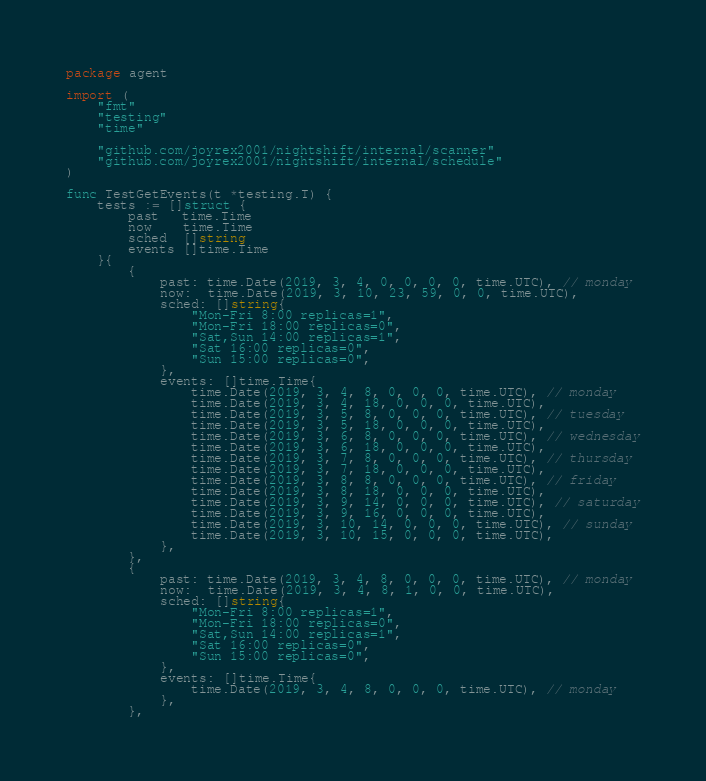<code> <loc_0><loc_0><loc_500><loc_500><_Go_>package agent

import (
	"fmt"
	"testing"
	"time"

	"github.com/joyrex2001/nightshift/internal/scanner"
	"github.com/joyrex2001/nightshift/internal/schedule"
)

func TestGetEvents(t *testing.T) {
	tests := []struct {
		past   time.Time
		now    time.Time
		sched  []string
		events []time.Time
	}{
		{
			past: time.Date(2019, 3, 4, 0, 0, 0, 0, time.UTC), // monday
			now:  time.Date(2019, 3, 10, 23, 59, 0, 0, time.UTC),
			sched: []string{
				"Mon-Fri 8:00 replicas=1",
				"Mon-Fri 18:00 replicas=0",
				"Sat,Sun 14:00 replicas=1",
				"Sat 16:00 replicas=0",
				"Sun 15:00 replicas=0",
			},
			events: []time.Time{
				time.Date(2019, 3, 4, 8, 0, 0, 0, time.UTC), // monday
				time.Date(2019, 3, 4, 18, 0, 0, 0, time.UTC),
				time.Date(2019, 3, 5, 8, 0, 0, 0, time.UTC), // tuesday
				time.Date(2019, 3, 5, 18, 0, 0, 0, time.UTC),
				time.Date(2019, 3, 6, 8, 0, 0, 0, time.UTC), // wednesday
				time.Date(2019, 3, 6, 18, 0, 0, 0, time.UTC),
				time.Date(2019, 3, 7, 8, 0, 0, 0, time.UTC), // thursday
				time.Date(2019, 3, 7, 18, 0, 0, 0, time.UTC),
				time.Date(2019, 3, 8, 8, 0, 0, 0, time.UTC), // friday
				time.Date(2019, 3, 8, 18, 0, 0, 0, time.UTC),
				time.Date(2019, 3, 9, 14, 0, 0, 0, time.UTC), // saturday
				time.Date(2019, 3, 9, 16, 0, 0, 0, time.UTC),
				time.Date(2019, 3, 10, 14, 0, 0, 0, time.UTC), // sunday
				time.Date(2019, 3, 10, 15, 0, 0, 0, time.UTC),
			},
		},
		{
			past: time.Date(2019, 3, 4, 8, 0, 0, 0, time.UTC), // monday
			now:  time.Date(2019, 3, 4, 8, 1, 0, 0, time.UTC),
			sched: []string{
				"Mon-Fri 8:00 replicas=1",
				"Mon-Fri 18:00 replicas=0",
				"Sat,Sun 14:00 replicas=1",
				"Sat 16:00 replicas=0",
				"Sun 15:00 replicas=0",
			},
			events: []time.Time{
				time.Date(2019, 3, 4, 8, 0, 0, 0, time.UTC), // monday
			},
		},</code> 